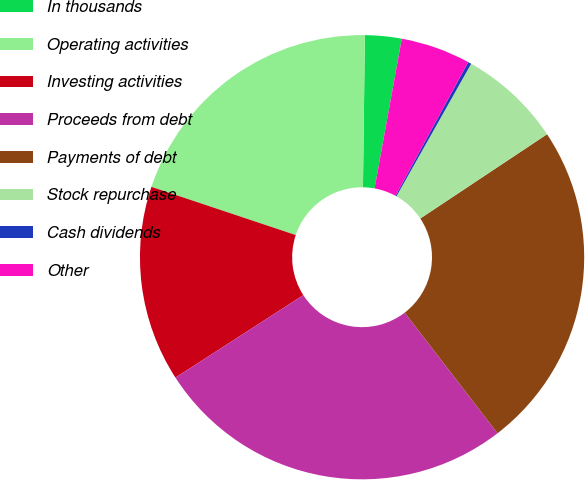<chart> <loc_0><loc_0><loc_500><loc_500><pie_chart><fcel>In thousands<fcel>Operating activities<fcel>Investing activities<fcel>Proceeds from debt<fcel>Payments of debt<fcel>Stock repurchase<fcel>Cash dividends<fcel>Other<nl><fcel>2.66%<fcel>20.07%<fcel>14.25%<fcel>26.32%<fcel>23.9%<fcel>7.49%<fcel>0.24%<fcel>5.07%<nl></chart> 